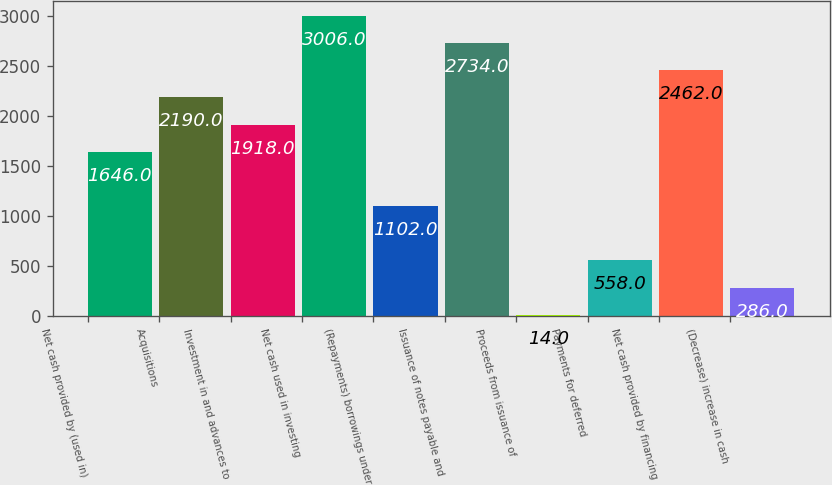Convert chart to OTSL. <chart><loc_0><loc_0><loc_500><loc_500><bar_chart><fcel>Net cash provided by (used in)<fcel>Acquisitions<fcel>Investment in and advances to<fcel>Net cash used in investing<fcel>(Repayments) borrowings under<fcel>Issuance of notes payable and<fcel>Proceeds from issuance of<fcel>Payments for deferred<fcel>Net cash provided by financing<fcel>(Decrease) increase in cash<nl><fcel>1646<fcel>2190<fcel>1918<fcel>3006<fcel>1102<fcel>2734<fcel>14<fcel>558<fcel>2462<fcel>286<nl></chart> 